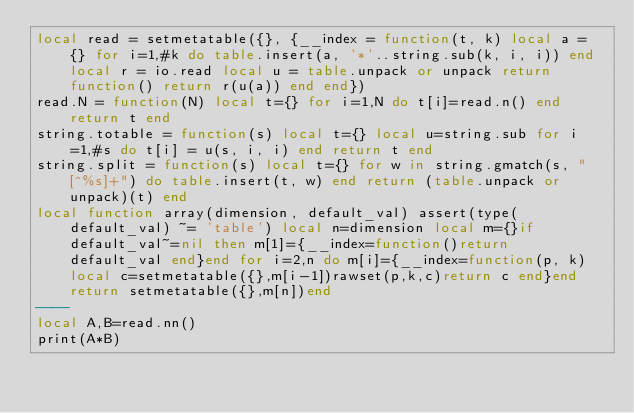<code> <loc_0><loc_0><loc_500><loc_500><_Lua_>local read = setmetatable({}, {__index = function(t, k) local a = {} for i=1,#k do table.insert(a, '*'..string.sub(k, i, i)) end local r = io.read local u = table.unpack or unpack return function() return r(u(a)) end end})
read.N = function(N) local t={} for i=1,N do t[i]=read.n() end return t end
string.totable = function(s) local t={} local u=string.sub for i=1,#s do t[i] = u(s, i, i) end return t end
string.split = function(s) local t={} for w in string.gmatch(s, "[^%s]+") do table.insert(t, w) end return (table.unpack or unpack)(t) end
local function array(dimension, default_val) assert(type(default_val) ~= 'table') local n=dimension local m={}if default_val~=nil then m[1]={__index=function()return default_val end}end for i=2,n do m[i]={__index=function(p, k)local c=setmetatable({},m[i-1])rawset(p,k,c)return c end}end return setmetatable({},m[n])end
----
local A,B=read.nn()
print(A*B)</code> 